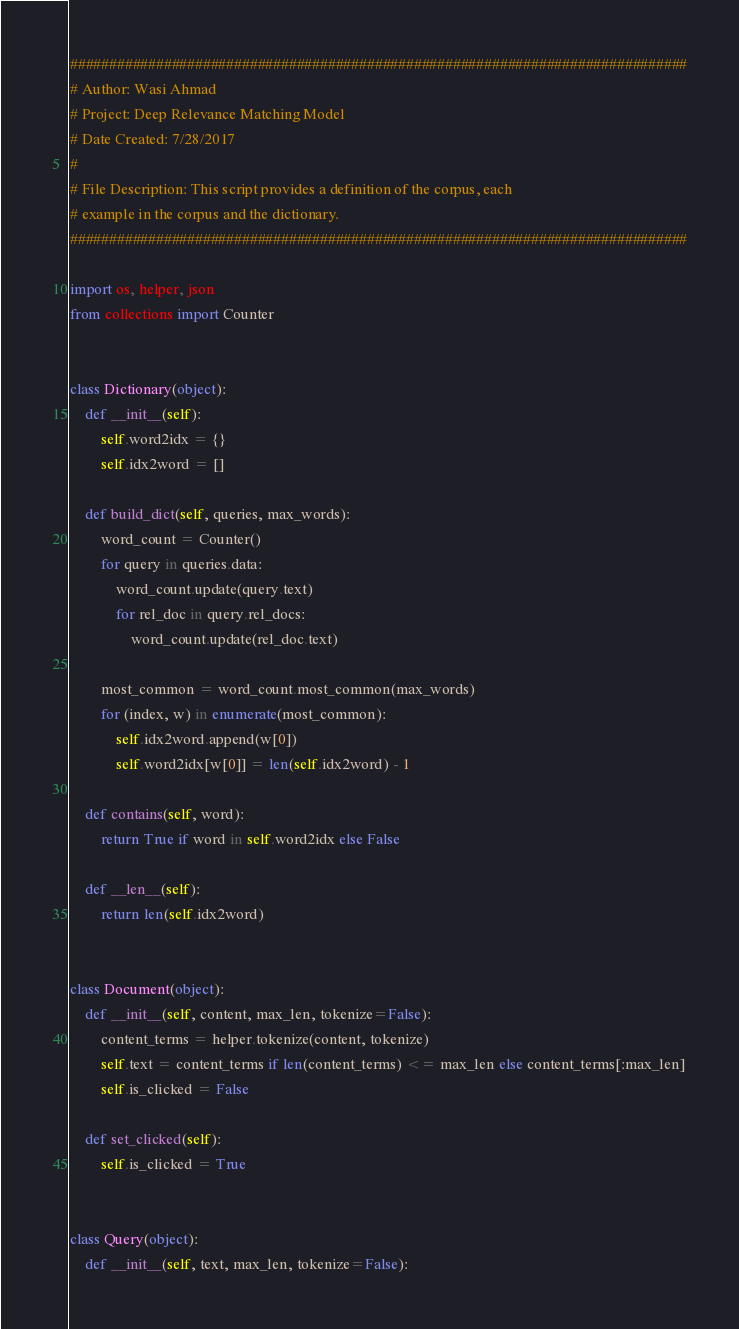Convert code to text. <code><loc_0><loc_0><loc_500><loc_500><_Python_>###############################################################################
# Author: Wasi Ahmad
# Project: Deep Relevance Matching Model
# Date Created: 7/28/2017
#
# File Description: This script provides a definition of the corpus, each
# example in the corpus and the dictionary.
###############################################################################

import os, helper, json
from collections import Counter


class Dictionary(object):
    def __init__(self):
        self.word2idx = {}
        self.idx2word = []

    def build_dict(self, queries, max_words):
        word_count = Counter()
        for query in queries.data:
            word_count.update(query.text)
            for rel_doc in query.rel_docs:
                word_count.update(rel_doc.text)

        most_common = word_count.most_common(max_words)
        for (index, w) in enumerate(most_common):
            self.idx2word.append(w[0])
            self.word2idx[w[0]] = len(self.idx2word) - 1

    def contains(self, word):
        return True if word in self.word2idx else False

    def __len__(self):
        return len(self.idx2word)


class Document(object):
    def __init__(self, content, max_len, tokenize=False):
        content_terms = helper.tokenize(content, tokenize)
        self.text = content_terms if len(content_terms) <= max_len else content_terms[:max_len]
        self.is_clicked = False

    def set_clicked(self):
        self.is_clicked = True


class Query(object):
    def __init__(self, text, max_len, tokenize=False):</code> 